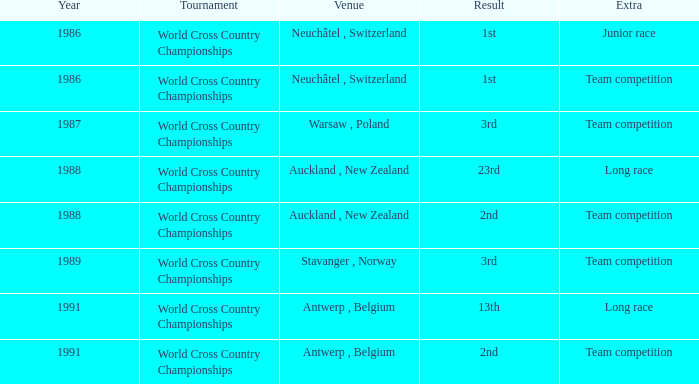At which location did the outcome result in a 13th place finish and included an additional long race? Antwerp , Belgium. 